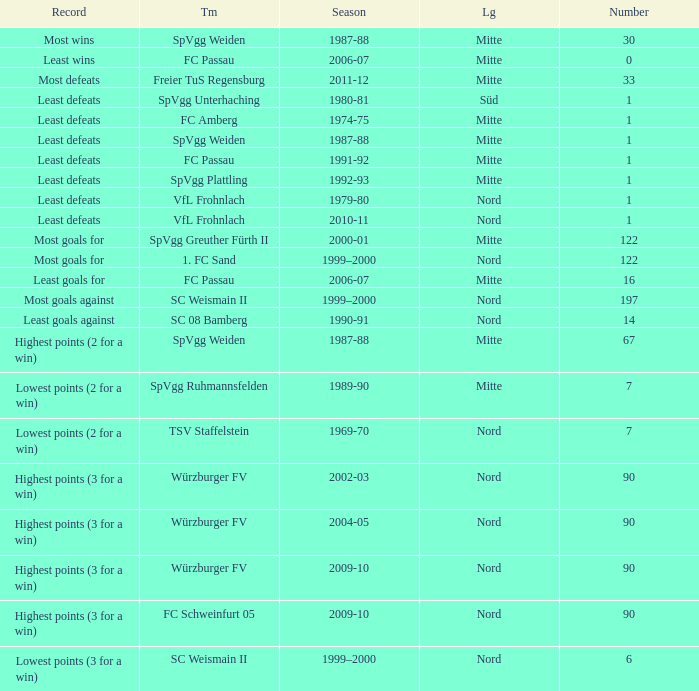What league has a number less than 1? Mitte. 